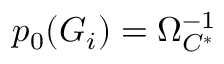<formula> <loc_0><loc_0><loc_500><loc_500>p _ { 0 } ( G _ { i } ) = \Omega _ { C ^ { * } } ^ { - 1 }</formula> 